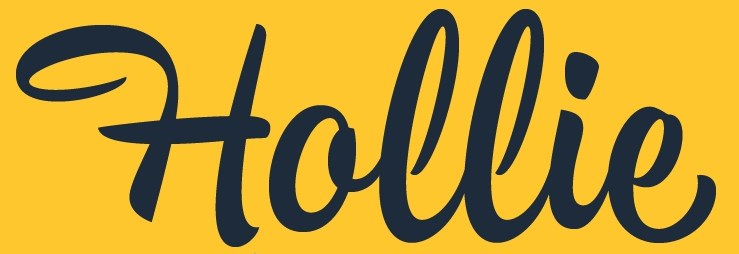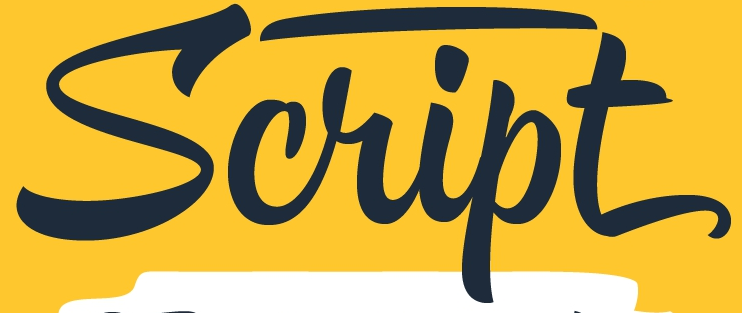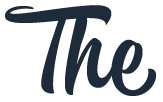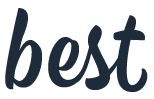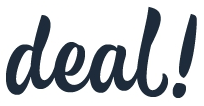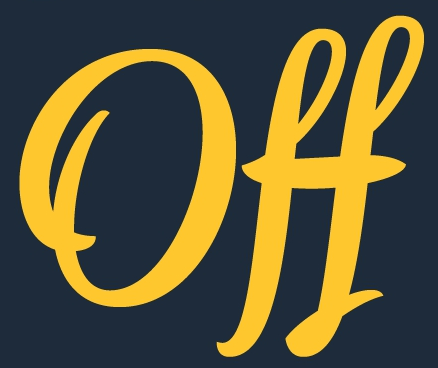What text appears in these images from left to right, separated by a semicolon? Hollie; Script; The; best; deal!; Off 